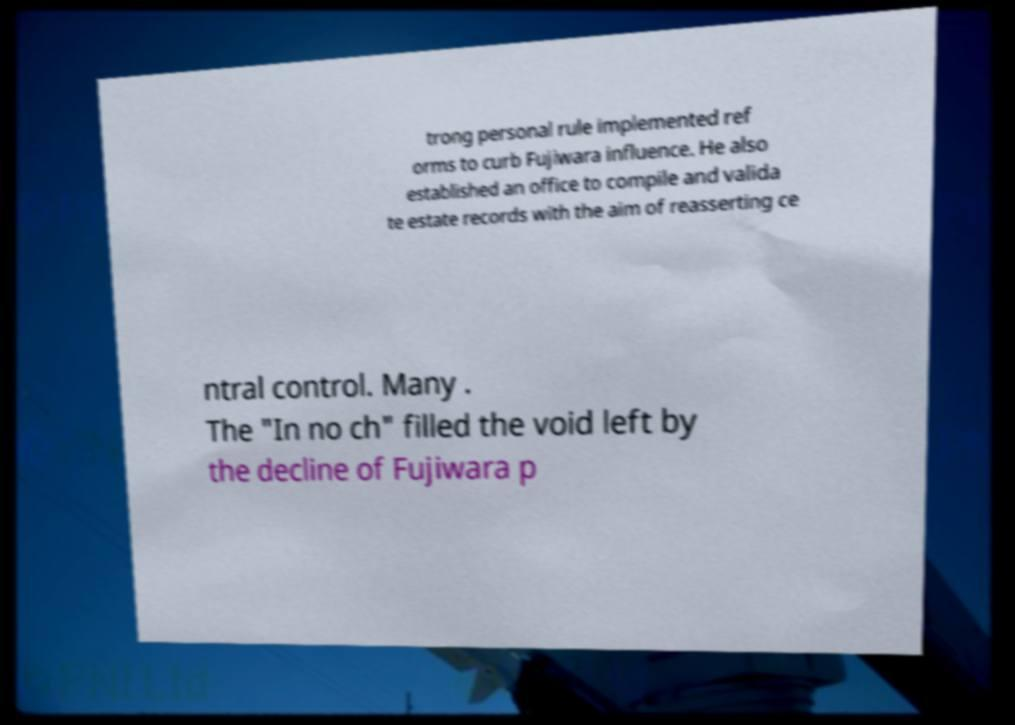Please read and relay the text visible in this image. What does it say? trong personal rule implemented ref orms to curb Fujiwara influence. He also established an office to compile and valida te estate records with the aim of reasserting ce ntral control. Many . The "In no ch" filled the void left by the decline of Fujiwara p 